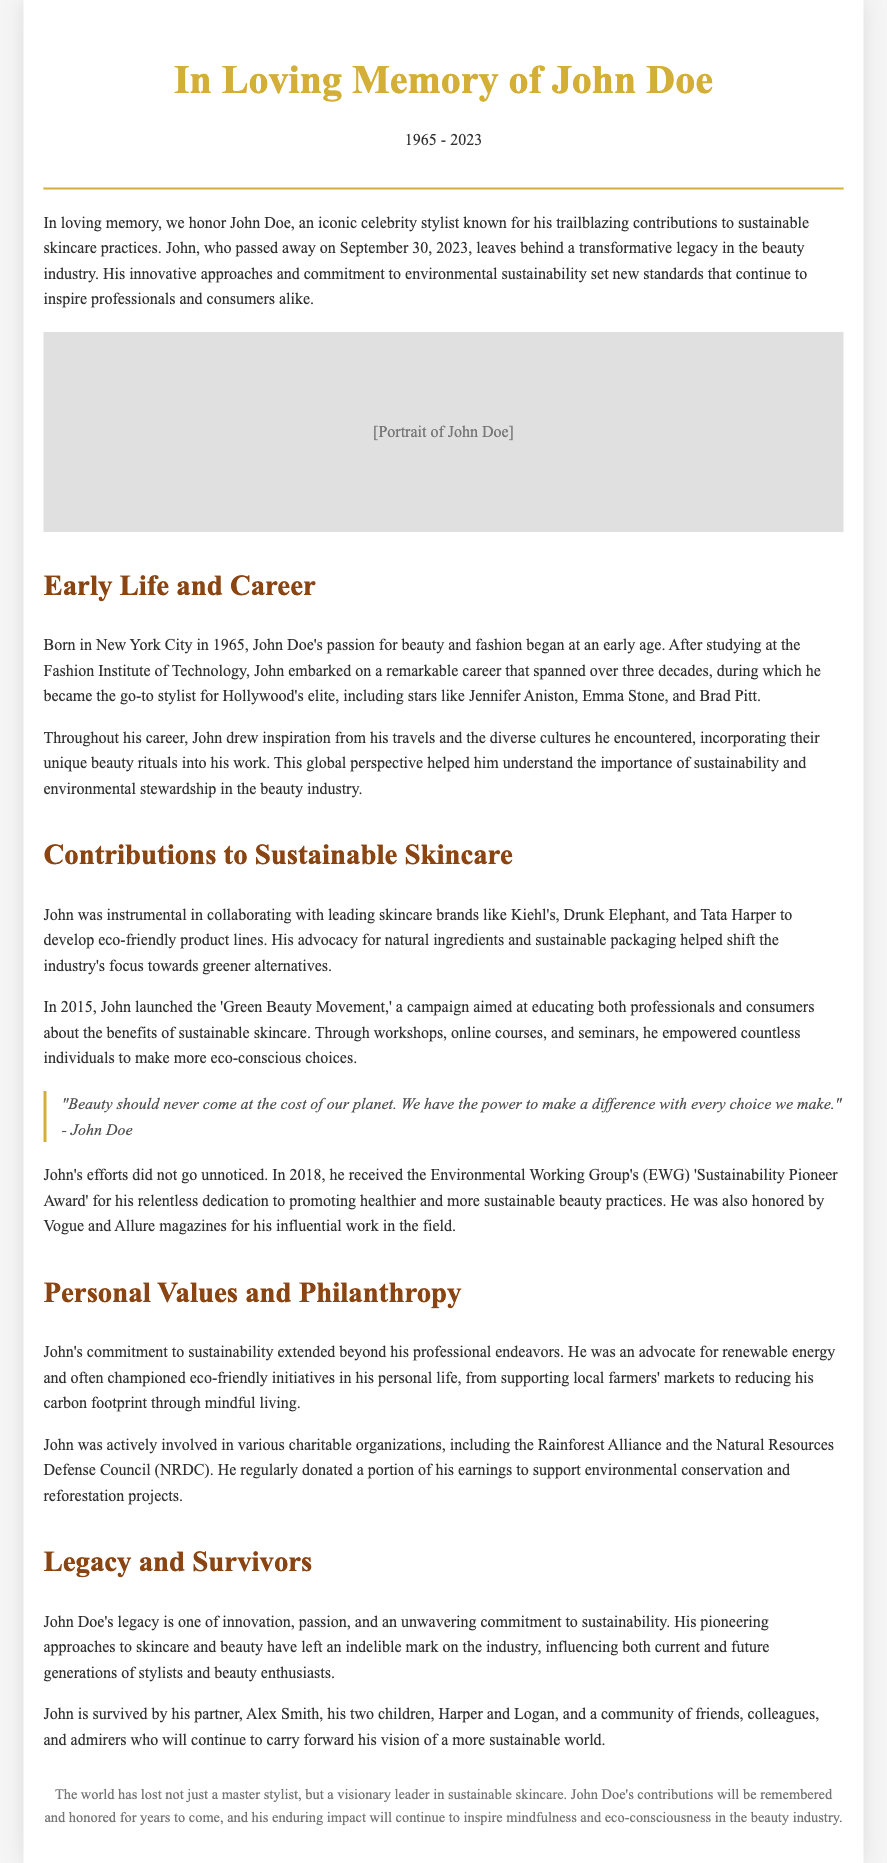what was John Doe's birth year? The document states that John Doe was born in 1965.
Answer: 1965 when did John Doe pass away? The document mentions that John Doe passed away on September 30, 2023.
Answer: September 30, 2023 which eco-friendly brands did John collaborate with? The document lists brands like Kiehl's, Drunk Elephant, and Tata Harper that John collaborated with for eco-friendly product lines.
Answer: Kiehl's, Drunk Elephant, Tata Harper what award did John receive in 2018? The document states that John received the Environmental Working Group's 'Sustainability Pioneer Award' in 2018.
Answer: Sustainability Pioneer Award how many children did John have? The document indicates that John is survived by his two children, Harper and Logan.
Answer: two what movement did John launch in 2015? The document mentions that in 2015, John launched the 'Green Beauty Movement.'
Answer: Green Beauty Movement what was one of John's personal commitments? The document refers to John's commitment to renewable energy as part of his personal values.
Answer: renewable energy what did John advocate for in the beauty industry? The document highlights John's advocacy for natural ingredients and sustainable packaging.
Answer: natural ingredients and sustainable packaging who is one of John Doe’s survivors? The document lists Alex Smith as one of John’s survivors.
Answer: Alex Smith 